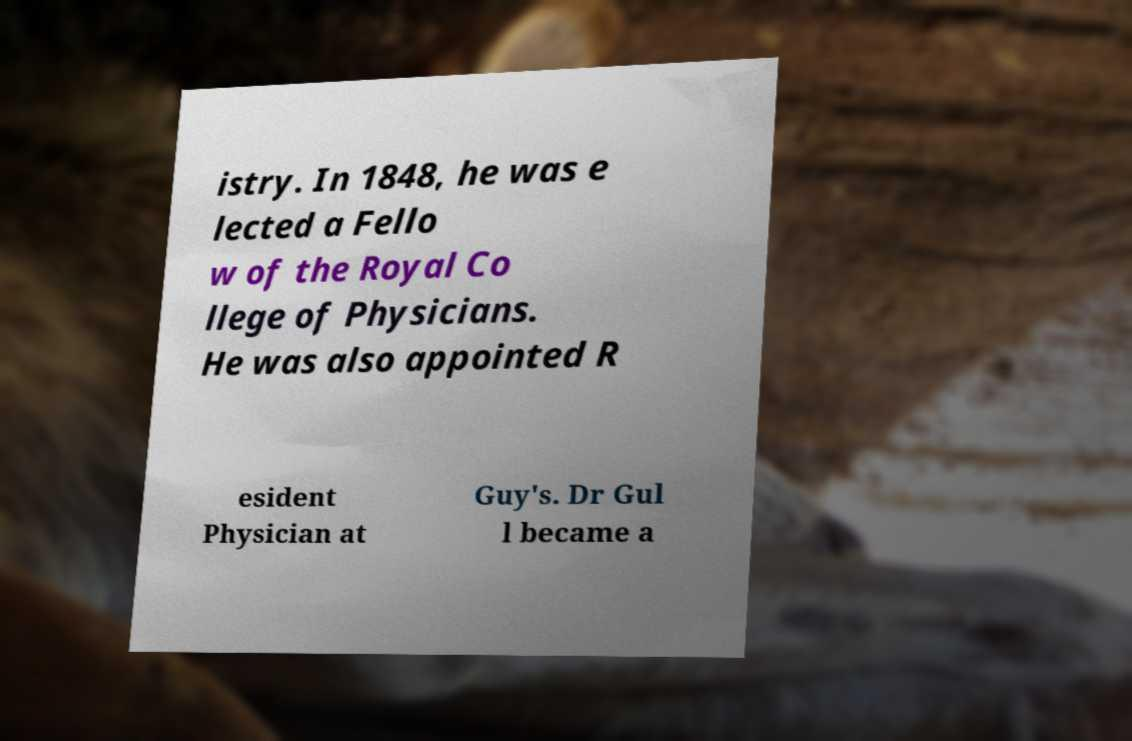Please read and relay the text visible in this image. What does it say? istry. In 1848, he was e lected a Fello w of the Royal Co llege of Physicians. He was also appointed R esident Physician at Guy's. Dr Gul l became a 